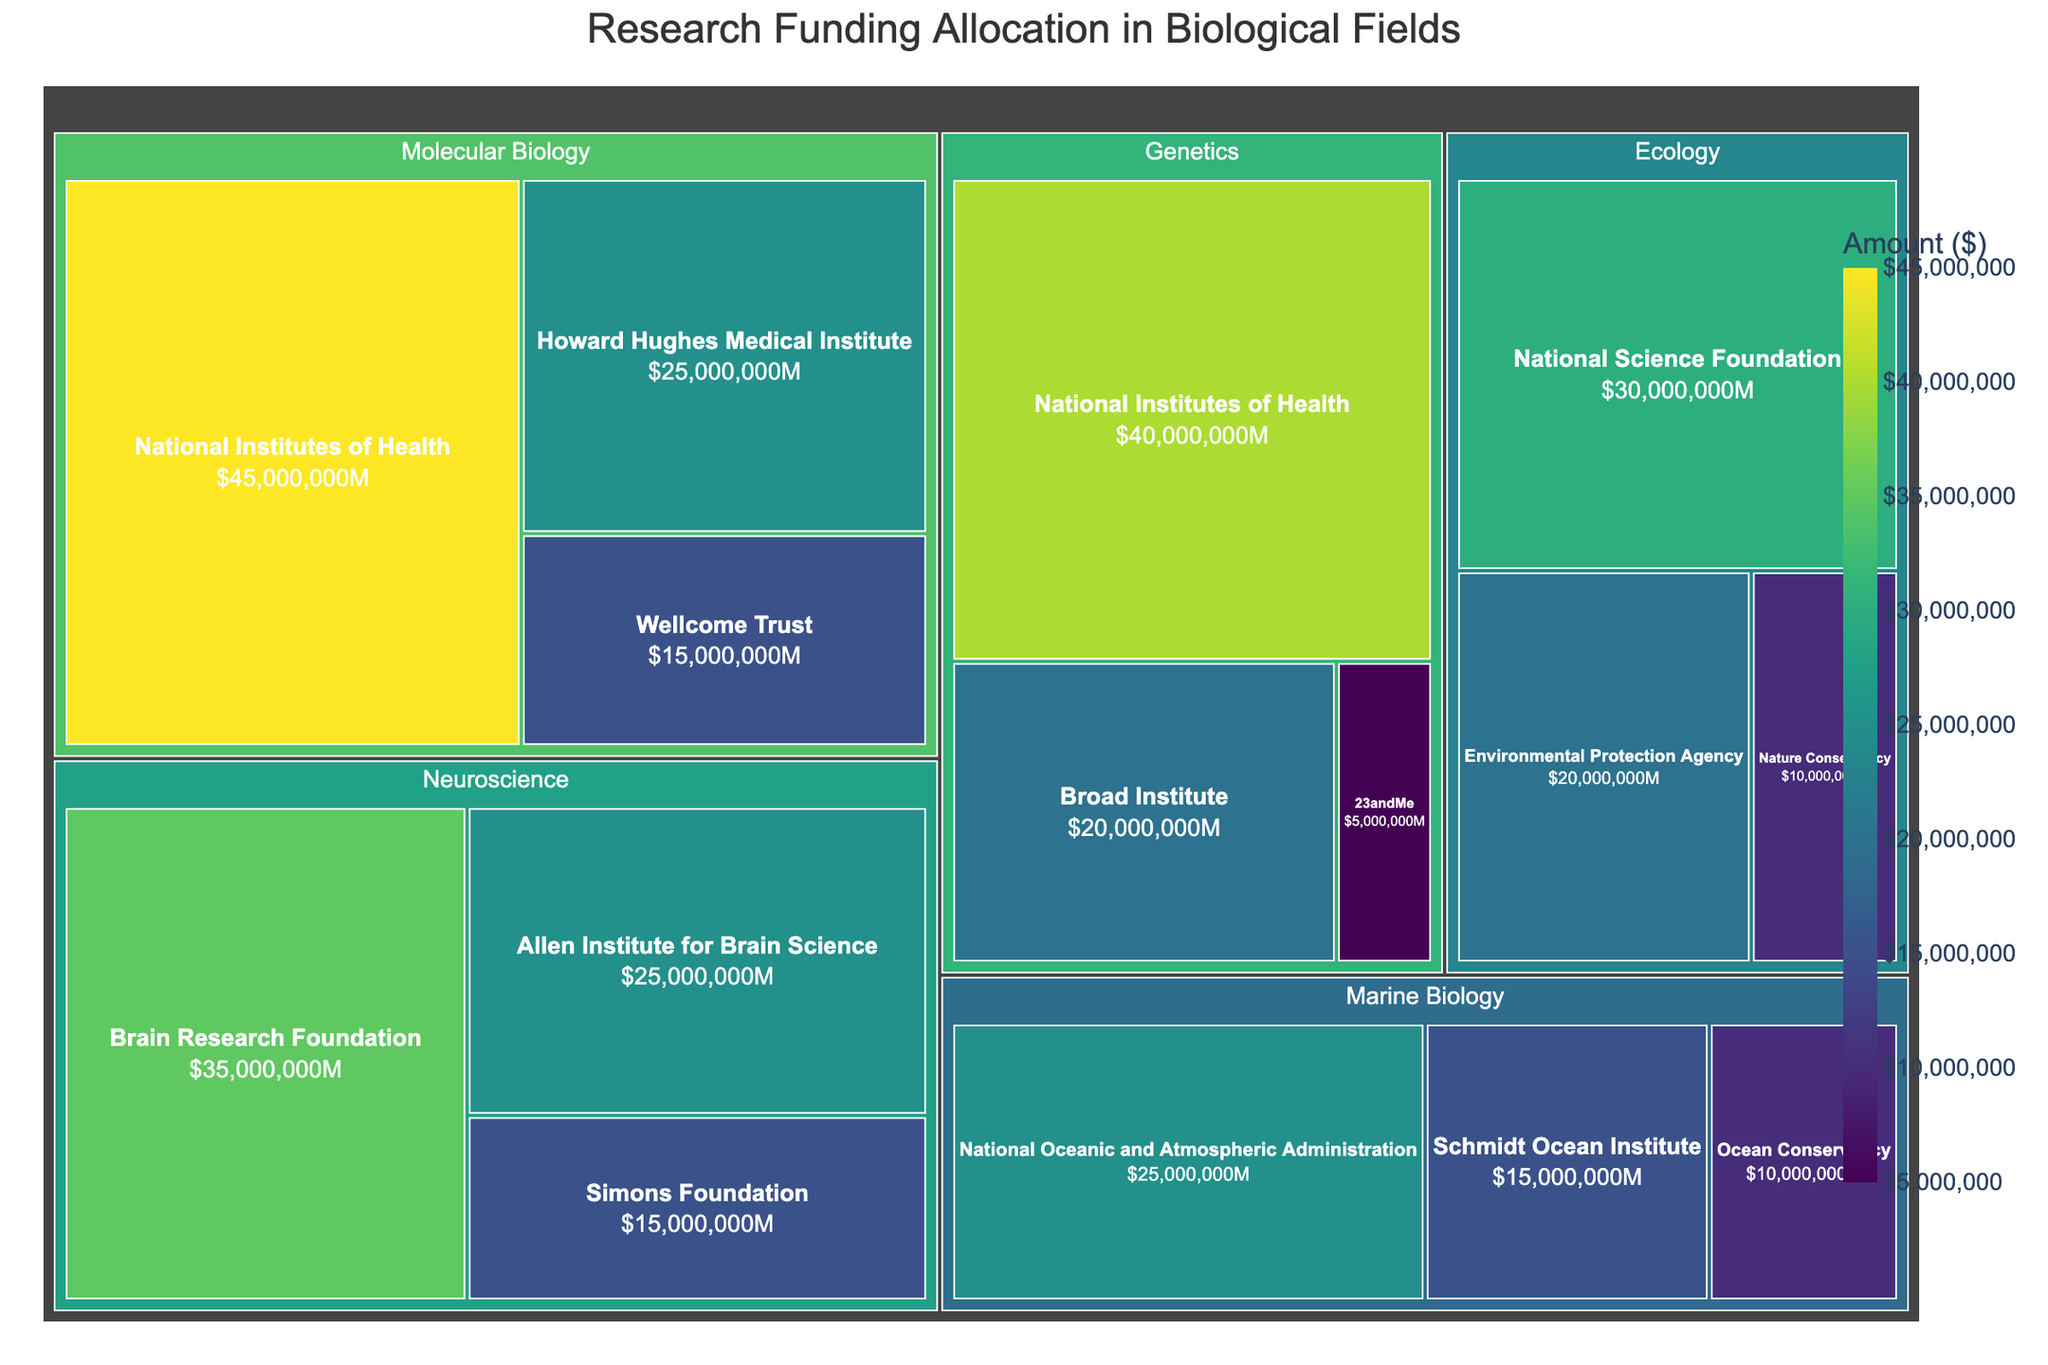What is the title of the treemap? The title of the treemap is displayed at the top of the figure, centered for better visibility.
Answer: Research Funding Allocation in Biological Fields Which funding source for Molecular Biology has the highest allocation? By looking at the section labeled "Molecular Biology" within the treemap, each funding source is displayed with its corresponding amount. The largest box within Molecular Biology represents the highest allocation.
Answer: National Institutes of Health What is the total funding amount allocated to Neuroscience? Summing the amounts from each funding source under the "Neuroscience" section: 35,000,000 + 25,000,000 + 15,000,000.
Answer: $75,000,000 Which field has the smallest total funding allocation? By comparing the total values of each field's section, the field with the smallest combined total will be the one with the smallest visual area.
Answer: Marine Biology How does the funding from the National Institutes of Health compare in Molecular Biology versus Genetics? The amount allocated by the National Institutes of Health in the Molecular Biology and Genetics sections needs to be compared directly
Answer: 45,000,000 (Molecular Biology) vs. 40,000,000 (Genetics) How much more funding does Ecology receive from the National Science Foundation compared to the Environmental Protection Agency? The difference between the amounts allocated by the National Science Foundation and the Environmental Protection Agency within the Ecology section needs to be calculated: 30,000,000 - 20,000,000.
Answer: $10,000,000 What is the average amount of funding received by the fields of study listed under Genetics? Summing the amounts from each funding source under the "Genetics" section and dividing by the number of sources: (40,000,000 + 20,000,000 + 5,000,000) / 3.
Answer: $21,666,666.67 Which field's leading funding source (by amount) is the Allen Institute for Brain Science? Within each field, identify the leading funding source by the largest amount, and check if any match the Allen Institute for Brain Science's allocation.
Answer: Neuroscience What percentage of Molecular Biology's funding is provided by the Wellcome Trust? Calculate the total funding in Molecular Biology to find the percentage contribution of the Wellcome Trust's allocation: (15,000,000 / (45,000,000 + 25,000,000 + 15,000,000)) * 100%.
Answer: 18.75% Which funding source is common to both Molecular Biology and Genetics, and how much total funding do they provide across both fields? Identify the common funding source between Molecular Biology and Genetics, then sum up its allocation in both sections.
Answer: National Institutes of Health, $85,000,000 